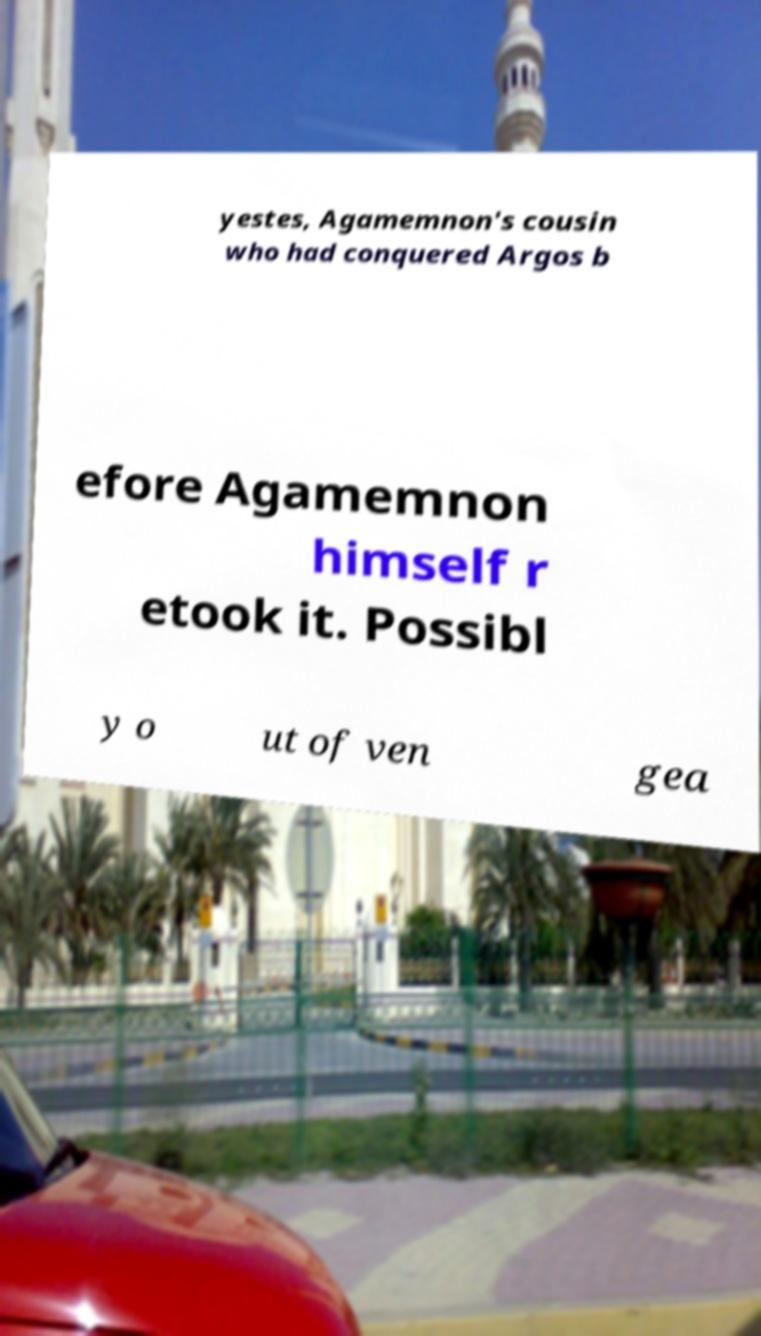Please read and relay the text visible in this image. What does it say? yestes, Agamemnon's cousin who had conquered Argos b efore Agamemnon himself r etook it. Possibl y o ut of ven gea 